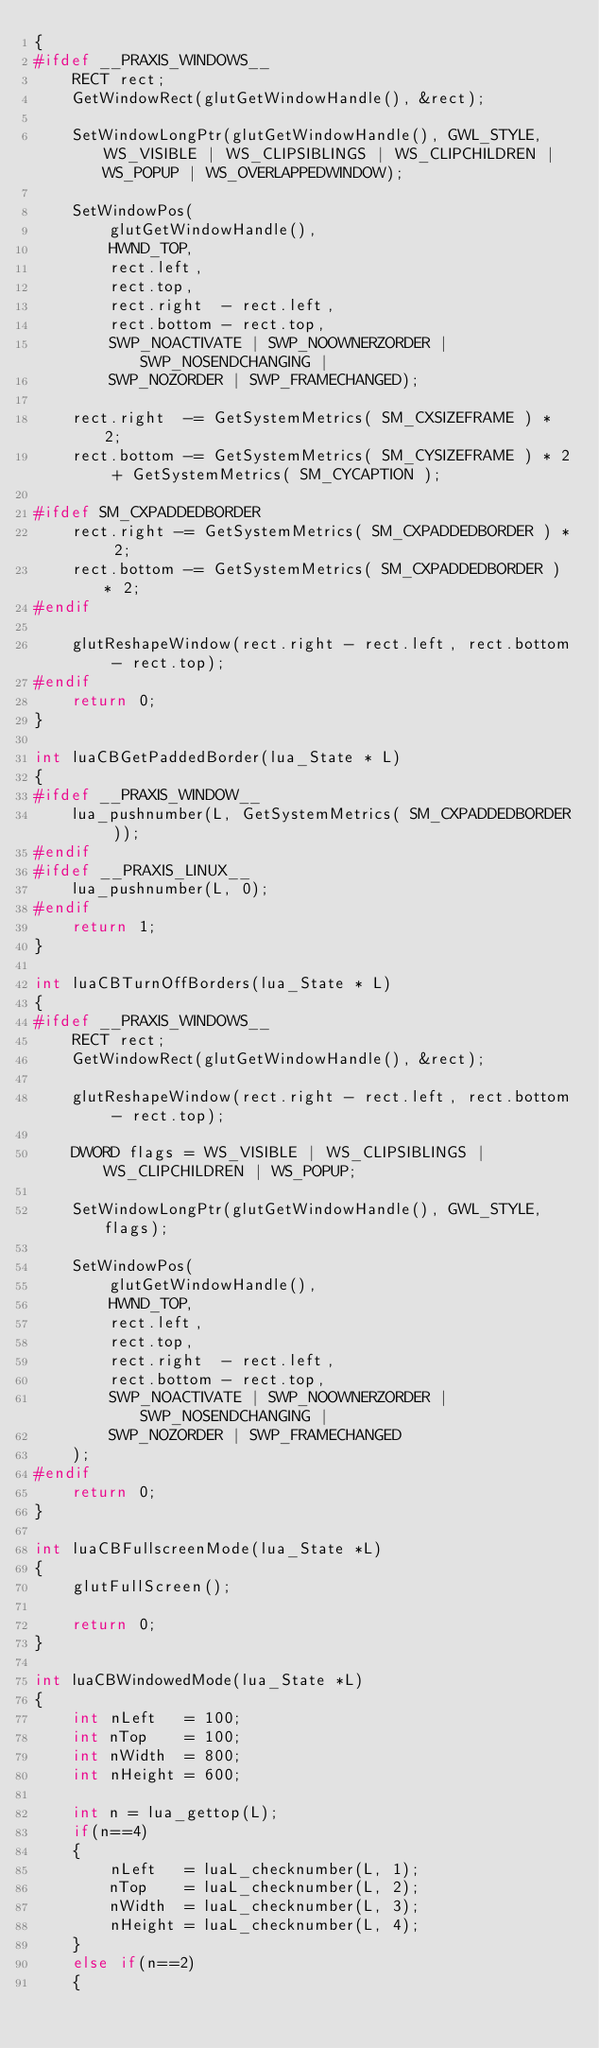<code> <loc_0><loc_0><loc_500><loc_500><_C++_>{
#ifdef __PRAXIS_WINDOWS__
    RECT rect;
    GetWindowRect(glutGetWindowHandle(), &rect);

    SetWindowLongPtr(glutGetWindowHandle(), GWL_STYLE, WS_VISIBLE | WS_CLIPSIBLINGS | WS_CLIPCHILDREN | WS_POPUP | WS_OVERLAPPEDWINDOW);

    SetWindowPos(
        glutGetWindowHandle(),
        HWND_TOP,
        rect.left,
        rect.top,
        rect.right  - rect.left,
        rect.bottom - rect.top,
        SWP_NOACTIVATE | SWP_NOOWNERZORDER | SWP_NOSENDCHANGING |
        SWP_NOZORDER | SWP_FRAMECHANGED);

    rect.right  -= GetSystemMetrics( SM_CXSIZEFRAME ) * 2;
    rect.bottom -= GetSystemMetrics( SM_CYSIZEFRAME ) * 2 + GetSystemMetrics( SM_CYCAPTION );

#ifdef SM_CXPADDEDBORDER
    rect.right -= GetSystemMetrics( SM_CXPADDEDBORDER ) * 2;
    rect.bottom -= GetSystemMetrics( SM_CXPADDEDBORDER ) * 2;
#endif

    glutReshapeWindow(rect.right - rect.left, rect.bottom - rect.top);
#endif
    return 0;
}

int luaCBGetPaddedBorder(lua_State * L)
{
#ifdef __PRAXIS_WINDOW__
    lua_pushnumber(L, GetSystemMetrics( SM_CXPADDEDBORDER ));
#endif
#ifdef __PRAXIS_LINUX__
    lua_pushnumber(L, 0);
#endif
    return 1;
}

int luaCBTurnOffBorders(lua_State * L)
{
#ifdef __PRAXIS_WINDOWS__
    RECT rect;
    GetWindowRect(glutGetWindowHandle(), &rect);

    glutReshapeWindow(rect.right - rect.left, rect.bottom - rect.top);

    DWORD flags = WS_VISIBLE | WS_CLIPSIBLINGS | WS_CLIPCHILDREN | WS_POPUP;

    SetWindowLongPtr(glutGetWindowHandle(), GWL_STYLE, flags);

    SetWindowPos(
        glutGetWindowHandle(),
        HWND_TOP,
        rect.left,
        rect.top,
        rect.right  - rect.left,
        rect.bottom - rect.top,
        SWP_NOACTIVATE | SWP_NOOWNERZORDER | SWP_NOSENDCHANGING |
        SWP_NOZORDER | SWP_FRAMECHANGED
    );
#endif
    return 0;
}

int luaCBFullscreenMode(lua_State *L)
{
    glutFullScreen();

    return 0;
}

int luaCBWindowedMode(lua_State *L)
{
    int nLeft   = 100;
    int nTop    = 100;
    int nWidth  = 800;
    int nHeight = 600;

    int n = lua_gettop(L);
    if(n==4)
    {
        nLeft   = luaL_checknumber(L, 1);
        nTop    = luaL_checknumber(L, 2);
        nWidth  = luaL_checknumber(L, 3);
        nHeight = luaL_checknumber(L, 4);
    }
    else if(n==2)
    {</code> 